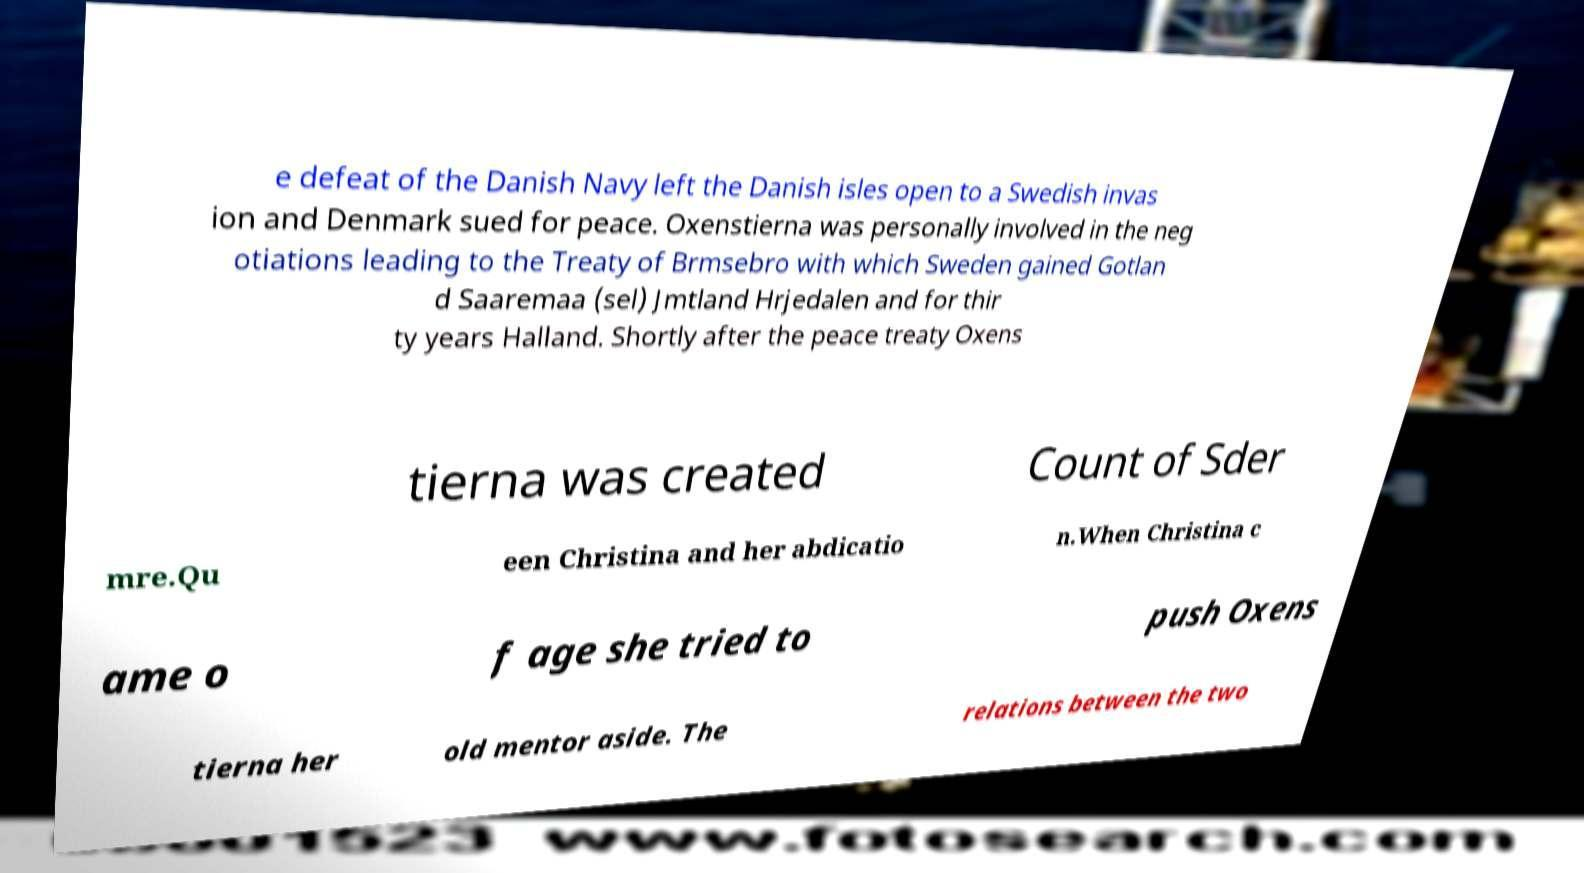Please identify and transcribe the text found in this image. e defeat of the Danish Navy left the Danish isles open to a Swedish invas ion and Denmark sued for peace. Oxenstierna was personally involved in the neg otiations leading to the Treaty of Brmsebro with which Sweden gained Gotlan d Saaremaa (sel) Jmtland Hrjedalen and for thir ty years Halland. Shortly after the peace treaty Oxens tierna was created Count of Sder mre.Qu een Christina and her abdicatio n.When Christina c ame o f age she tried to push Oxens tierna her old mentor aside. The relations between the two 